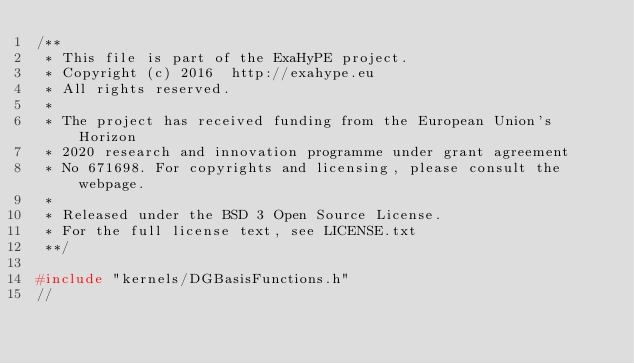Convert code to text. <code><loc_0><loc_0><loc_500><loc_500><_C++_>/**
 * This file is part of the ExaHyPE project.
 * Copyright (c) 2016  http://exahype.eu
 * All rights reserved.
 *
 * The project has received funding from the European Union's Horizon 
 * 2020 research and innovation programme under grant agreement
 * No 671698. For copyrights and licensing, please consult the webpage.
 *
 * Released under the BSD 3 Open Source License.
 * For the full license text, see LICENSE.txt
 **/
 
#include "kernels/DGBasisFunctions.h"
//</code> 